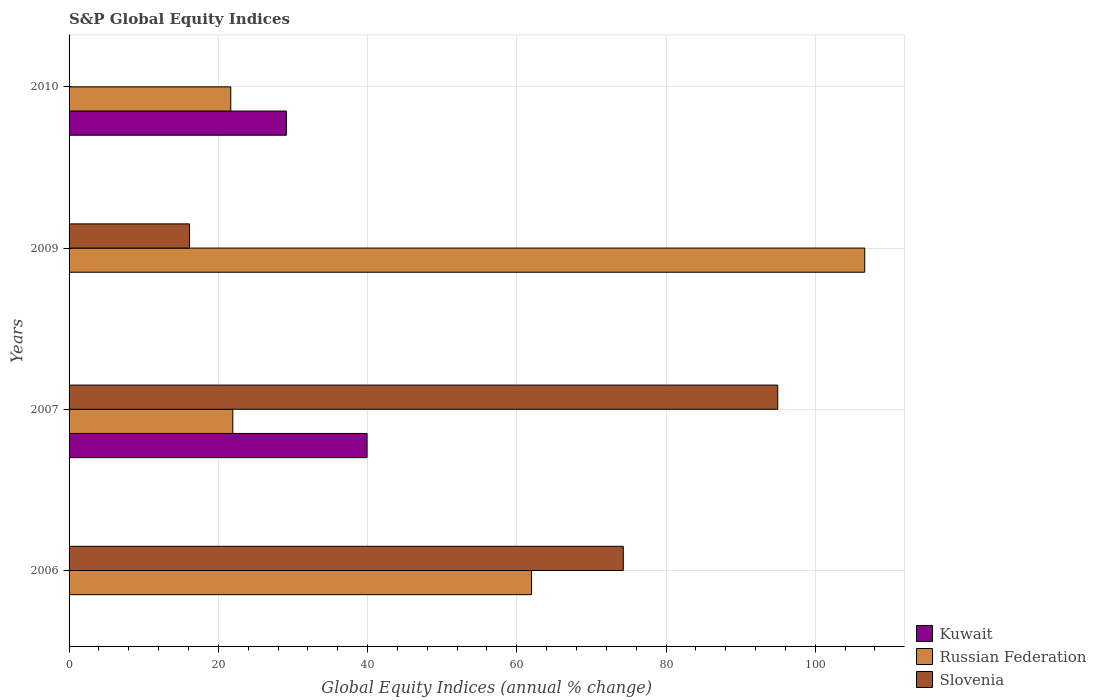How many different coloured bars are there?
Provide a short and direct response. 3. How many groups of bars are there?
Provide a short and direct response. 4. How many bars are there on the 1st tick from the bottom?
Ensure brevity in your answer.  2. Across all years, what is the maximum global equity indices in Slovenia?
Make the answer very short. 94.97. Across all years, what is the minimum global equity indices in Russian Federation?
Provide a succinct answer. 21.67. What is the total global equity indices in Slovenia in the graph?
Ensure brevity in your answer.  185.39. What is the difference between the global equity indices in Slovenia in 2007 and that in 2009?
Provide a succinct answer. 78.83. What is the difference between the global equity indices in Russian Federation in 2006 and the global equity indices in Kuwait in 2010?
Keep it short and to the point. 32.86. What is the average global equity indices in Slovenia per year?
Your response must be concise. 46.35. In the year 2007, what is the difference between the global equity indices in Kuwait and global equity indices in Russian Federation?
Offer a very short reply. 18. What is the ratio of the global equity indices in Russian Federation in 2007 to that in 2010?
Offer a very short reply. 1.01. Is the global equity indices in Russian Federation in 2009 less than that in 2010?
Keep it short and to the point. No. Is the difference between the global equity indices in Kuwait in 2007 and 2010 greater than the difference between the global equity indices in Russian Federation in 2007 and 2010?
Give a very brief answer. Yes. What is the difference between the highest and the second highest global equity indices in Slovenia?
Provide a short and direct response. 20.7. What is the difference between the highest and the lowest global equity indices in Kuwait?
Offer a terse response. 39.94. In how many years, is the global equity indices in Slovenia greater than the average global equity indices in Slovenia taken over all years?
Make the answer very short. 2. How many bars are there?
Keep it short and to the point. 9. Are the values on the major ticks of X-axis written in scientific E-notation?
Your response must be concise. No. Does the graph contain grids?
Offer a very short reply. Yes. How many legend labels are there?
Offer a terse response. 3. What is the title of the graph?
Your answer should be compact. S&P Global Equity Indices. What is the label or title of the X-axis?
Offer a terse response. Global Equity Indices (annual % change). What is the Global Equity Indices (annual % change) of Russian Federation in 2006?
Your answer should be very brief. 61.98. What is the Global Equity Indices (annual % change) in Slovenia in 2006?
Provide a short and direct response. 74.27. What is the Global Equity Indices (annual % change) in Kuwait in 2007?
Your answer should be very brief. 39.94. What is the Global Equity Indices (annual % change) of Russian Federation in 2007?
Your answer should be very brief. 21.94. What is the Global Equity Indices (annual % change) of Slovenia in 2007?
Offer a very short reply. 94.97. What is the Global Equity Indices (annual % change) of Russian Federation in 2009?
Give a very brief answer. 106.63. What is the Global Equity Indices (annual % change) in Slovenia in 2009?
Offer a terse response. 16.14. What is the Global Equity Indices (annual % change) of Kuwait in 2010?
Offer a terse response. 29.12. What is the Global Equity Indices (annual % change) of Russian Federation in 2010?
Your answer should be compact. 21.67. Across all years, what is the maximum Global Equity Indices (annual % change) in Kuwait?
Give a very brief answer. 39.94. Across all years, what is the maximum Global Equity Indices (annual % change) in Russian Federation?
Give a very brief answer. 106.63. Across all years, what is the maximum Global Equity Indices (annual % change) of Slovenia?
Your answer should be compact. 94.97. Across all years, what is the minimum Global Equity Indices (annual % change) in Russian Federation?
Make the answer very short. 21.67. Across all years, what is the minimum Global Equity Indices (annual % change) in Slovenia?
Your answer should be compact. 0. What is the total Global Equity Indices (annual % change) in Kuwait in the graph?
Your answer should be very brief. 69.06. What is the total Global Equity Indices (annual % change) in Russian Federation in the graph?
Your answer should be compact. 212.23. What is the total Global Equity Indices (annual % change) in Slovenia in the graph?
Offer a terse response. 185.39. What is the difference between the Global Equity Indices (annual % change) in Russian Federation in 2006 and that in 2007?
Keep it short and to the point. 40.04. What is the difference between the Global Equity Indices (annual % change) of Slovenia in 2006 and that in 2007?
Give a very brief answer. -20.7. What is the difference between the Global Equity Indices (annual % change) in Russian Federation in 2006 and that in 2009?
Your response must be concise. -44.65. What is the difference between the Global Equity Indices (annual % change) in Slovenia in 2006 and that in 2009?
Your answer should be compact. 58.13. What is the difference between the Global Equity Indices (annual % change) in Russian Federation in 2006 and that in 2010?
Your answer should be compact. 40.31. What is the difference between the Global Equity Indices (annual % change) of Russian Federation in 2007 and that in 2009?
Offer a terse response. -84.69. What is the difference between the Global Equity Indices (annual % change) in Slovenia in 2007 and that in 2009?
Offer a terse response. 78.83. What is the difference between the Global Equity Indices (annual % change) in Kuwait in 2007 and that in 2010?
Make the answer very short. 10.81. What is the difference between the Global Equity Indices (annual % change) in Russian Federation in 2007 and that in 2010?
Provide a succinct answer. 0.27. What is the difference between the Global Equity Indices (annual % change) in Russian Federation in 2009 and that in 2010?
Keep it short and to the point. 84.96. What is the difference between the Global Equity Indices (annual % change) of Russian Federation in 2006 and the Global Equity Indices (annual % change) of Slovenia in 2007?
Ensure brevity in your answer.  -32.99. What is the difference between the Global Equity Indices (annual % change) of Russian Federation in 2006 and the Global Equity Indices (annual % change) of Slovenia in 2009?
Provide a succinct answer. 45.84. What is the difference between the Global Equity Indices (annual % change) of Kuwait in 2007 and the Global Equity Indices (annual % change) of Russian Federation in 2009?
Offer a terse response. -66.69. What is the difference between the Global Equity Indices (annual % change) in Kuwait in 2007 and the Global Equity Indices (annual % change) in Slovenia in 2009?
Provide a short and direct response. 23.8. What is the difference between the Global Equity Indices (annual % change) in Russian Federation in 2007 and the Global Equity Indices (annual % change) in Slovenia in 2009?
Make the answer very short. 5.8. What is the difference between the Global Equity Indices (annual % change) in Kuwait in 2007 and the Global Equity Indices (annual % change) in Russian Federation in 2010?
Your answer should be compact. 18.27. What is the average Global Equity Indices (annual % change) in Kuwait per year?
Make the answer very short. 17.27. What is the average Global Equity Indices (annual % change) in Russian Federation per year?
Keep it short and to the point. 53.06. What is the average Global Equity Indices (annual % change) in Slovenia per year?
Provide a succinct answer. 46.35. In the year 2006, what is the difference between the Global Equity Indices (annual % change) in Russian Federation and Global Equity Indices (annual % change) in Slovenia?
Offer a terse response. -12.29. In the year 2007, what is the difference between the Global Equity Indices (annual % change) of Kuwait and Global Equity Indices (annual % change) of Russian Federation?
Make the answer very short. 18. In the year 2007, what is the difference between the Global Equity Indices (annual % change) in Kuwait and Global Equity Indices (annual % change) in Slovenia?
Make the answer very short. -55.03. In the year 2007, what is the difference between the Global Equity Indices (annual % change) in Russian Federation and Global Equity Indices (annual % change) in Slovenia?
Your answer should be compact. -73.03. In the year 2009, what is the difference between the Global Equity Indices (annual % change) of Russian Federation and Global Equity Indices (annual % change) of Slovenia?
Make the answer very short. 90.49. In the year 2010, what is the difference between the Global Equity Indices (annual % change) in Kuwait and Global Equity Indices (annual % change) in Russian Federation?
Give a very brief answer. 7.45. What is the ratio of the Global Equity Indices (annual % change) of Russian Federation in 2006 to that in 2007?
Provide a succinct answer. 2.82. What is the ratio of the Global Equity Indices (annual % change) in Slovenia in 2006 to that in 2007?
Offer a terse response. 0.78. What is the ratio of the Global Equity Indices (annual % change) of Russian Federation in 2006 to that in 2009?
Make the answer very short. 0.58. What is the ratio of the Global Equity Indices (annual % change) in Slovenia in 2006 to that in 2009?
Ensure brevity in your answer.  4.6. What is the ratio of the Global Equity Indices (annual % change) of Russian Federation in 2006 to that in 2010?
Provide a succinct answer. 2.86. What is the ratio of the Global Equity Indices (annual % change) of Russian Federation in 2007 to that in 2009?
Your response must be concise. 0.21. What is the ratio of the Global Equity Indices (annual % change) of Slovenia in 2007 to that in 2009?
Make the answer very short. 5.88. What is the ratio of the Global Equity Indices (annual % change) of Kuwait in 2007 to that in 2010?
Offer a terse response. 1.37. What is the ratio of the Global Equity Indices (annual % change) of Russian Federation in 2007 to that in 2010?
Offer a terse response. 1.01. What is the ratio of the Global Equity Indices (annual % change) in Russian Federation in 2009 to that in 2010?
Ensure brevity in your answer.  4.92. What is the difference between the highest and the second highest Global Equity Indices (annual % change) in Russian Federation?
Your response must be concise. 44.65. What is the difference between the highest and the second highest Global Equity Indices (annual % change) in Slovenia?
Your answer should be compact. 20.7. What is the difference between the highest and the lowest Global Equity Indices (annual % change) in Kuwait?
Offer a terse response. 39.94. What is the difference between the highest and the lowest Global Equity Indices (annual % change) in Russian Federation?
Give a very brief answer. 84.96. What is the difference between the highest and the lowest Global Equity Indices (annual % change) in Slovenia?
Make the answer very short. 94.97. 